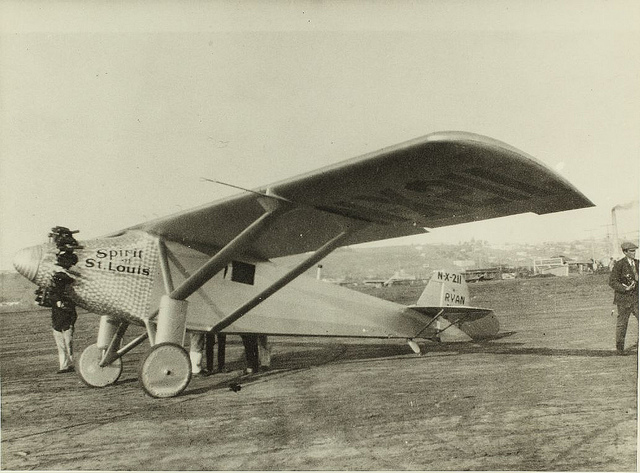Please transcribe the text in this image. Sprit St.louis N-X -2III RYAN 